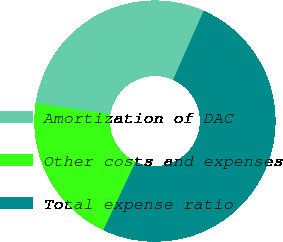Convert chart to OTSL. <chart><loc_0><loc_0><loc_500><loc_500><pie_chart><fcel>Amortization of DAC<fcel>Other costs and expenses<fcel>Total expense ratio<nl><fcel>29.22%<fcel>20.37%<fcel>50.41%<nl></chart> 